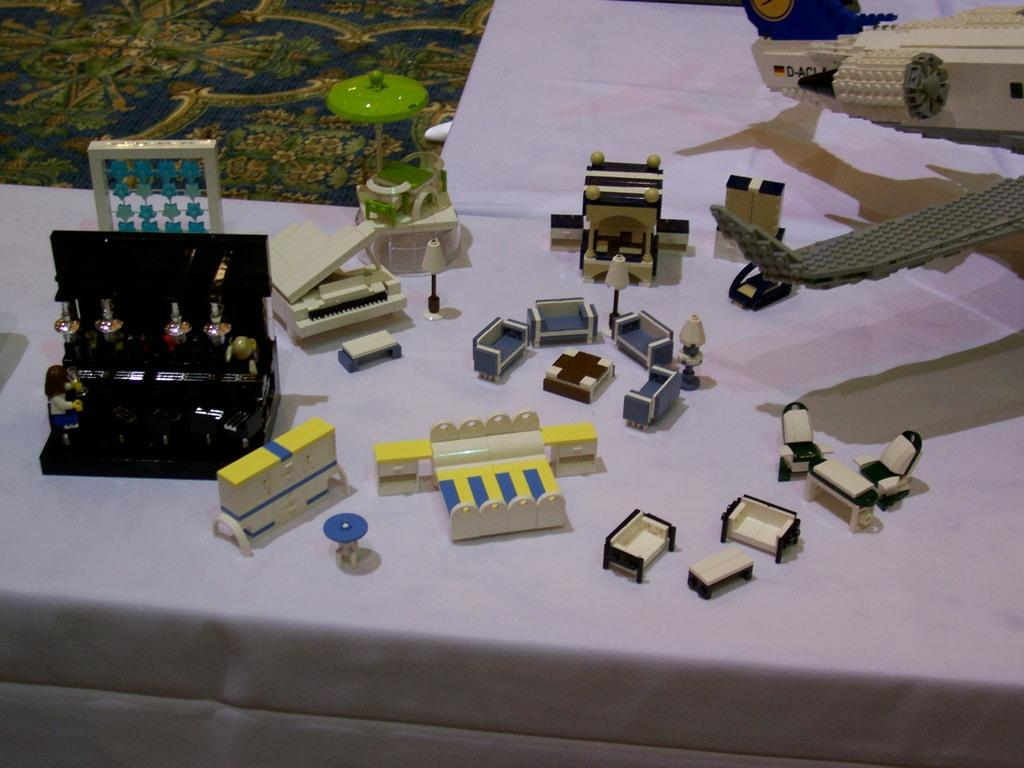What is located in the foreground of the image? There is a table in the foreground of the image. What items can be seen on the table? There are toys and building blocks on the table. What type of flooring is visible in the background of the image? There is a carpet in the background of the image. What type of canvas is the boy painting on in the image? There is no canvas or boy present in the image; it features a table with toys and building blocks. 